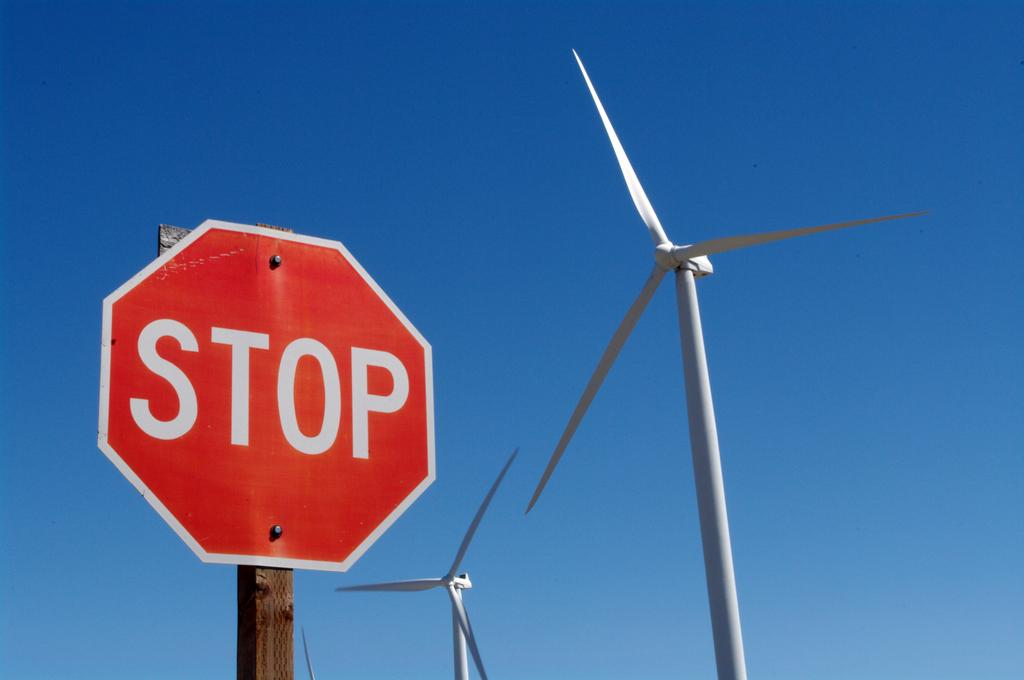<image>
Write a terse but informative summary of the picture. a STOP sign in front of two wind turbines 